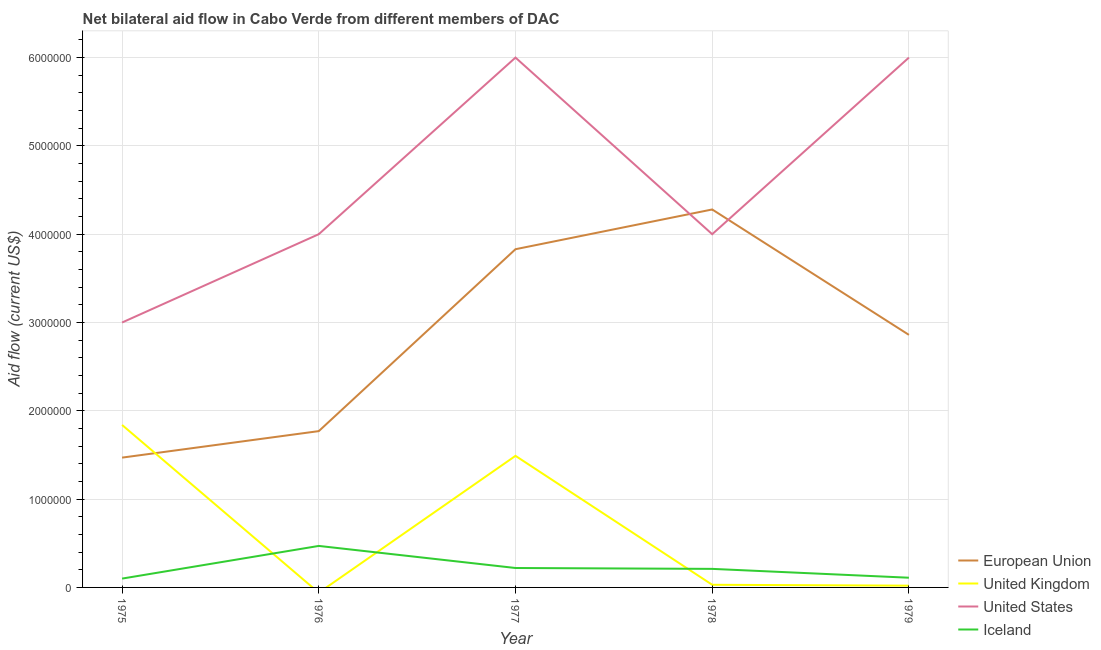How many different coloured lines are there?
Make the answer very short. 4. Is the number of lines equal to the number of legend labels?
Provide a succinct answer. No. What is the amount of aid given by uk in 1979?
Keep it short and to the point. 2.00e+04. Across all years, what is the maximum amount of aid given by eu?
Your response must be concise. 4.28e+06. Across all years, what is the minimum amount of aid given by iceland?
Give a very brief answer. 1.00e+05. In which year was the amount of aid given by iceland maximum?
Keep it short and to the point. 1976. What is the total amount of aid given by uk in the graph?
Your response must be concise. 3.38e+06. What is the difference between the amount of aid given by eu in 1976 and that in 1978?
Offer a very short reply. -2.51e+06. What is the difference between the amount of aid given by us in 1978 and the amount of aid given by iceland in 1977?
Make the answer very short. 3.78e+06. What is the average amount of aid given by iceland per year?
Provide a short and direct response. 2.22e+05. In the year 1979, what is the difference between the amount of aid given by iceland and amount of aid given by us?
Provide a succinct answer. -5.89e+06. In how many years, is the amount of aid given by uk greater than 1600000 US$?
Make the answer very short. 1. What is the ratio of the amount of aid given by uk in 1975 to that in 1979?
Your answer should be compact. 92. Is the difference between the amount of aid given by uk in 1977 and 1979 greater than the difference between the amount of aid given by us in 1977 and 1979?
Provide a succinct answer. Yes. What is the difference between the highest and the lowest amount of aid given by uk?
Make the answer very short. 1.84e+06. Is the sum of the amount of aid given by us in 1975 and 1979 greater than the maximum amount of aid given by iceland across all years?
Ensure brevity in your answer.  Yes. Is it the case that in every year, the sum of the amount of aid given by eu and amount of aid given by iceland is greater than the sum of amount of aid given by uk and amount of aid given by us?
Your answer should be very brief. No. Does the amount of aid given by eu monotonically increase over the years?
Make the answer very short. No. Is the amount of aid given by eu strictly less than the amount of aid given by uk over the years?
Your response must be concise. No. How many lines are there?
Your answer should be compact. 4. How many years are there in the graph?
Your answer should be very brief. 5. Where does the legend appear in the graph?
Provide a succinct answer. Bottom right. What is the title of the graph?
Give a very brief answer. Net bilateral aid flow in Cabo Verde from different members of DAC. Does "Water" appear as one of the legend labels in the graph?
Your response must be concise. No. What is the label or title of the Y-axis?
Provide a succinct answer. Aid flow (current US$). What is the Aid flow (current US$) of European Union in 1975?
Make the answer very short. 1.47e+06. What is the Aid flow (current US$) in United Kingdom in 1975?
Your answer should be very brief. 1.84e+06. What is the Aid flow (current US$) of United States in 1975?
Make the answer very short. 3.00e+06. What is the Aid flow (current US$) in Iceland in 1975?
Provide a short and direct response. 1.00e+05. What is the Aid flow (current US$) in European Union in 1976?
Offer a terse response. 1.77e+06. What is the Aid flow (current US$) in United Kingdom in 1976?
Keep it short and to the point. 0. What is the Aid flow (current US$) of United States in 1976?
Your answer should be very brief. 4.00e+06. What is the Aid flow (current US$) of European Union in 1977?
Make the answer very short. 3.83e+06. What is the Aid flow (current US$) of United Kingdom in 1977?
Offer a very short reply. 1.49e+06. What is the Aid flow (current US$) in European Union in 1978?
Offer a terse response. 4.28e+06. What is the Aid flow (current US$) of United Kingdom in 1978?
Your response must be concise. 3.00e+04. What is the Aid flow (current US$) of European Union in 1979?
Your answer should be compact. 2.86e+06. What is the Aid flow (current US$) in United Kingdom in 1979?
Your answer should be compact. 2.00e+04. What is the Aid flow (current US$) of United States in 1979?
Provide a short and direct response. 6.00e+06. What is the Aid flow (current US$) of Iceland in 1979?
Ensure brevity in your answer.  1.10e+05. Across all years, what is the maximum Aid flow (current US$) in European Union?
Ensure brevity in your answer.  4.28e+06. Across all years, what is the maximum Aid flow (current US$) of United Kingdom?
Your response must be concise. 1.84e+06. Across all years, what is the maximum Aid flow (current US$) of Iceland?
Your answer should be very brief. 4.70e+05. Across all years, what is the minimum Aid flow (current US$) of European Union?
Make the answer very short. 1.47e+06. What is the total Aid flow (current US$) of European Union in the graph?
Provide a succinct answer. 1.42e+07. What is the total Aid flow (current US$) in United Kingdom in the graph?
Give a very brief answer. 3.38e+06. What is the total Aid flow (current US$) of United States in the graph?
Your answer should be compact. 2.30e+07. What is the total Aid flow (current US$) of Iceland in the graph?
Give a very brief answer. 1.11e+06. What is the difference between the Aid flow (current US$) of Iceland in 1975 and that in 1976?
Your answer should be very brief. -3.70e+05. What is the difference between the Aid flow (current US$) of European Union in 1975 and that in 1977?
Your response must be concise. -2.36e+06. What is the difference between the Aid flow (current US$) in United Kingdom in 1975 and that in 1977?
Keep it short and to the point. 3.50e+05. What is the difference between the Aid flow (current US$) of United States in 1975 and that in 1977?
Your response must be concise. -3.00e+06. What is the difference between the Aid flow (current US$) in Iceland in 1975 and that in 1977?
Keep it short and to the point. -1.20e+05. What is the difference between the Aid flow (current US$) in European Union in 1975 and that in 1978?
Your answer should be very brief. -2.81e+06. What is the difference between the Aid flow (current US$) in United Kingdom in 1975 and that in 1978?
Make the answer very short. 1.81e+06. What is the difference between the Aid flow (current US$) of United States in 1975 and that in 1978?
Make the answer very short. -1.00e+06. What is the difference between the Aid flow (current US$) in European Union in 1975 and that in 1979?
Your answer should be very brief. -1.39e+06. What is the difference between the Aid flow (current US$) in United Kingdom in 1975 and that in 1979?
Make the answer very short. 1.82e+06. What is the difference between the Aid flow (current US$) in United States in 1975 and that in 1979?
Offer a very short reply. -3.00e+06. What is the difference between the Aid flow (current US$) in Iceland in 1975 and that in 1979?
Offer a very short reply. -10000. What is the difference between the Aid flow (current US$) of European Union in 1976 and that in 1977?
Provide a succinct answer. -2.06e+06. What is the difference between the Aid flow (current US$) in Iceland in 1976 and that in 1977?
Give a very brief answer. 2.50e+05. What is the difference between the Aid flow (current US$) in European Union in 1976 and that in 1978?
Give a very brief answer. -2.51e+06. What is the difference between the Aid flow (current US$) in United States in 1976 and that in 1978?
Give a very brief answer. 0. What is the difference between the Aid flow (current US$) of European Union in 1976 and that in 1979?
Ensure brevity in your answer.  -1.09e+06. What is the difference between the Aid flow (current US$) in United States in 1976 and that in 1979?
Your answer should be compact. -2.00e+06. What is the difference between the Aid flow (current US$) of European Union in 1977 and that in 1978?
Give a very brief answer. -4.50e+05. What is the difference between the Aid flow (current US$) of United Kingdom in 1977 and that in 1978?
Give a very brief answer. 1.46e+06. What is the difference between the Aid flow (current US$) of European Union in 1977 and that in 1979?
Offer a terse response. 9.70e+05. What is the difference between the Aid flow (current US$) of United Kingdom in 1977 and that in 1979?
Offer a very short reply. 1.47e+06. What is the difference between the Aid flow (current US$) in Iceland in 1977 and that in 1979?
Make the answer very short. 1.10e+05. What is the difference between the Aid flow (current US$) in European Union in 1978 and that in 1979?
Ensure brevity in your answer.  1.42e+06. What is the difference between the Aid flow (current US$) in United Kingdom in 1978 and that in 1979?
Your answer should be compact. 10000. What is the difference between the Aid flow (current US$) of Iceland in 1978 and that in 1979?
Give a very brief answer. 1.00e+05. What is the difference between the Aid flow (current US$) of European Union in 1975 and the Aid flow (current US$) of United States in 1976?
Make the answer very short. -2.53e+06. What is the difference between the Aid flow (current US$) in United Kingdom in 1975 and the Aid flow (current US$) in United States in 1976?
Your response must be concise. -2.16e+06. What is the difference between the Aid flow (current US$) of United Kingdom in 1975 and the Aid flow (current US$) of Iceland in 1976?
Your answer should be compact. 1.37e+06. What is the difference between the Aid flow (current US$) in United States in 1975 and the Aid flow (current US$) in Iceland in 1976?
Give a very brief answer. 2.53e+06. What is the difference between the Aid flow (current US$) in European Union in 1975 and the Aid flow (current US$) in United Kingdom in 1977?
Your answer should be compact. -2.00e+04. What is the difference between the Aid flow (current US$) in European Union in 1975 and the Aid flow (current US$) in United States in 1977?
Provide a short and direct response. -4.53e+06. What is the difference between the Aid flow (current US$) of European Union in 1975 and the Aid flow (current US$) of Iceland in 1977?
Keep it short and to the point. 1.25e+06. What is the difference between the Aid flow (current US$) of United Kingdom in 1975 and the Aid flow (current US$) of United States in 1977?
Ensure brevity in your answer.  -4.16e+06. What is the difference between the Aid flow (current US$) in United Kingdom in 1975 and the Aid flow (current US$) in Iceland in 1977?
Give a very brief answer. 1.62e+06. What is the difference between the Aid flow (current US$) of United States in 1975 and the Aid flow (current US$) of Iceland in 1977?
Provide a short and direct response. 2.78e+06. What is the difference between the Aid flow (current US$) in European Union in 1975 and the Aid flow (current US$) in United Kingdom in 1978?
Offer a very short reply. 1.44e+06. What is the difference between the Aid flow (current US$) of European Union in 1975 and the Aid flow (current US$) of United States in 1978?
Give a very brief answer. -2.53e+06. What is the difference between the Aid flow (current US$) in European Union in 1975 and the Aid flow (current US$) in Iceland in 1978?
Make the answer very short. 1.26e+06. What is the difference between the Aid flow (current US$) of United Kingdom in 1975 and the Aid flow (current US$) of United States in 1978?
Your answer should be compact. -2.16e+06. What is the difference between the Aid flow (current US$) of United Kingdom in 1975 and the Aid flow (current US$) of Iceland in 1978?
Offer a very short reply. 1.63e+06. What is the difference between the Aid flow (current US$) of United States in 1975 and the Aid flow (current US$) of Iceland in 1978?
Give a very brief answer. 2.79e+06. What is the difference between the Aid flow (current US$) of European Union in 1975 and the Aid flow (current US$) of United Kingdom in 1979?
Ensure brevity in your answer.  1.45e+06. What is the difference between the Aid flow (current US$) in European Union in 1975 and the Aid flow (current US$) in United States in 1979?
Your answer should be very brief. -4.53e+06. What is the difference between the Aid flow (current US$) of European Union in 1975 and the Aid flow (current US$) of Iceland in 1979?
Ensure brevity in your answer.  1.36e+06. What is the difference between the Aid flow (current US$) in United Kingdom in 1975 and the Aid flow (current US$) in United States in 1979?
Ensure brevity in your answer.  -4.16e+06. What is the difference between the Aid flow (current US$) of United Kingdom in 1975 and the Aid flow (current US$) of Iceland in 1979?
Keep it short and to the point. 1.73e+06. What is the difference between the Aid flow (current US$) in United States in 1975 and the Aid flow (current US$) in Iceland in 1979?
Your response must be concise. 2.89e+06. What is the difference between the Aid flow (current US$) of European Union in 1976 and the Aid flow (current US$) of United States in 1977?
Offer a very short reply. -4.23e+06. What is the difference between the Aid flow (current US$) in European Union in 1976 and the Aid flow (current US$) in Iceland in 1977?
Your answer should be compact. 1.55e+06. What is the difference between the Aid flow (current US$) in United States in 1976 and the Aid flow (current US$) in Iceland in 1977?
Provide a short and direct response. 3.78e+06. What is the difference between the Aid flow (current US$) in European Union in 1976 and the Aid flow (current US$) in United Kingdom in 1978?
Ensure brevity in your answer.  1.74e+06. What is the difference between the Aid flow (current US$) of European Union in 1976 and the Aid flow (current US$) of United States in 1978?
Provide a succinct answer. -2.23e+06. What is the difference between the Aid flow (current US$) in European Union in 1976 and the Aid flow (current US$) in Iceland in 1978?
Your response must be concise. 1.56e+06. What is the difference between the Aid flow (current US$) of United States in 1976 and the Aid flow (current US$) of Iceland in 1978?
Provide a succinct answer. 3.79e+06. What is the difference between the Aid flow (current US$) of European Union in 1976 and the Aid flow (current US$) of United Kingdom in 1979?
Make the answer very short. 1.75e+06. What is the difference between the Aid flow (current US$) in European Union in 1976 and the Aid flow (current US$) in United States in 1979?
Ensure brevity in your answer.  -4.23e+06. What is the difference between the Aid flow (current US$) of European Union in 1976 and the Aid flow (current US$) of Iceland in 1979?
Offer a very short reply. 1.66e+06. What is the difference between the Aid flow (current US$) in United States in 1976 and the Aid flow (current US$) in Iceland in 1979?
Provide a succinct answer. 3.89e+06. What is the difference between the Aid flow (current US$) of European Union in 1977 and the Aid flow (current US$) of United Kingdom in 1978?
Provide a short and direct response. 3.80e+06. What is the difference between the Aid flow (current US$) of European Union in 1977 and the Aid flow (current US$) of Iceland in 1978?
Provide a short and direct response. 3.62e+06. What is the difference between the Aid flow (current US$) of United Kingdom in 1977 and the Aid flow (current US$) of United States in 1978?
Keep it short and to the point. -2.51e+06. What is the difference between the Aid flow (current US$) of United Kingdom in 1977 and the Aid flow (current US$) of Iceland in 1978?
Make the answer very short. 1.28e+06. What is the difference between the Aid flow (current US$) in United States in 1977 and the Aid flow (current US$) in Iceland in 1978?
Provide a succinct answer. 5.79e+06. What is the difference between the Aid flow (current US$) in European Union in 1977 and the Aid flow (current US$) in United Kingdom in 1979?
Offer a very short reply. 3.81e+06. What is the difference between the Aid flow (current US$) of European Union in 1977 and the Aid flow (current US$) of United States in 1979?
Provide a short and direct response. -2.17e+06. What is the difference between the Aid flow (current US$) of European Union in 1977 and the Aid flow (current US$) of Iceland in 1979?
Your response must be concise. 3.72e+06. What is the difference between the Aid flow (current US$) in United Kingdom in 1977 and the Aid flow (current US$) in United States in 1979?
Your answer should be very brief. -4.51e+06. What is the difference between the Aid flow (current US$) of United Kingdom in 1977 and the Aid flow (current US$) of Iceland in 1979?
Provide a succinct answer. 1.38e+06. What is the difference between the Aid flow (current US$) in United States in 1977 and the Aid flow (current US$) in Iceland in 1979?
Give a very brief answer. 5.89e+06. What is the difference between the Aid flow (current US$) in European Union in 1978 and the Aid flow (current US$) in United Kingdom in 1979?
Give a very brief answer. 4.26e+06. What is the difference between the Aid flow (current US$) of European Union in 1978 and the Aid flow (current US$) of United States in 1979?
Make the answer very short. -1.72e+06. What is the difference between the Aid flow (current US$) of European Union in 1978 and the Aid flow (current US$) of Iceland in 1979?
Your answer should be compact. 4.17e+06. What is the difference between the Aid flow (current US$) in United Kingdom in 1978 and the Aid flow (current US$) in United States in 1979?
Provide a short and direct response. -5.97e+06. What is the difference between the Aid flow (current US$) in United Kingdom in 1978 and the Aid flow (current US$) in Iceland in 1979?
Provide a short and direct response. -8.00e+04. What is the difference between the Aid flow (current US$) of United States in 1978 and the Aid flow (current US$) of Iceland in 1979?
Offer a very short reply. 3.89e+06. What is the average Aid flow (current US$) in European Union per year?
Give a very brief answer. 2.84e+06. What is the average Aid flow (current US$) in United Kingdom per year?
Provide a succinct answer. 6.76e+05. What is the average Aid flow (current US$) of United States per year?
Provide a short and direct response. 4.60e+06. What is the average Aid flow (current US$) in Iceland per year?
Your response must be concise. 2.22e+05. In the year 1975, what is the difference between the Aid flow (current US$) in European Union and Aid flow (current US$) in United Kingdom?
Offer a terse response. -3.70e+05. In the year 1975, what is the difference between the Aid flow (current US$) of European Union and Aid flow (current US$) of United States?
Keep it short and to the point. -1.53e+06. In the year 1975, what is the difference between the Aid flow (current US$) in European Union and Aid flow (current US$) in Iceland?
Ensure brevity in your answer.  1.37e+06. In the year 1975, what is the difference between the Aid flow (current US$) of United Kingdom and Aid flow (current US$) of United States?
Provide a short and direct response. -1.16e+06. In the year 1975, what is the difference between the Aid flow (current US$) of United Kingdom and Aid flow (current US$) of Iceland?
Your answer should be compact. 1.74e+06. In the year 1975, what is the difference between the Aid flow (current US$) in United States and Aid flow (current US$) in Iceland?
Offer a very short reply. 2.90e+06. In the year 1976, what is the difference between the Aid flow (current US$) in European Union and Aid flow (current US$) in United States?
Ensure brevity in your answer.  -2.23e+06. In the year 1976, what is the difference between the Aid flow (current US$) of European Union and Aid flow (current US$) of Iceland?
Provide a succinct answer. 1.30e+06. In the year 1976, what is the difference between the Aid flow (current US$) of United States and Aid flow (current US$) of Iceland?
Provide a short and direct response. 3.53e+06. In the year 1977, what is the difference between the Aid flow (current US$) in European Union and Aid flow (current US$) in United Kingdom?
Give a very brief answer. 2.34e+06. In the year 1977, what is the difference between the Aid flow (current US$) of European Union and Aid flow (current US$) of United States?
Provide a short and direct response. -2.17e+06. In the year 1977, what is the difference between the Aid flow (current US$) in European Union and Aid flow (current US$) in Iceland?
Give a very brief answer. 3.61e+06. In the year 1977, what is the difference between the Aid flow (current US$) in United Kingdom and Aid flow (current US$) in United States?
Offer a very short reply. -4.51e+06. In the year 1977, what is the difference between the Aid flow (current US$) of United Kingdom and Aid flow (current US$) of Iceland?
Keep it short and to the point. 1.27e+06. In the year 1977, what is the difference between the Aid flow (current US$) in United States and Aid flow (current US$) in Iceland?
Offer a terse response. 5.78e+06. In the year 1978, what is the difference between the Aid flow (current US$) of European Union and Aid flow (current US$) of United Kingdom?
Ensure brevity in your answer.  4.25e+06. In the year 1978, what is the difference between the Aid flow (current US$) of European Union and Aid flow (current US$) of United States?
Your answer should be compact. 2.80e+05. In the year 1978, what is the difference between the Aid flow (current US$) in European Union and Aid flow (current US$) in Iceland?
Keep it short and to the point. 4.07e+06. In the year 1978, what is the difference between the Aid flow (current US$) of United Kingdom and Aid flow (current US$) of United States?
Your answer should be very brief. -3.97e+06. In the year 1978, what is the difference between the Aid flow (current US$) in United States and Aid flow (current US$) in Iceland?
Ensure brevity in your answer.  3.79e+06. In the year 1979, what is the difference between the Aid flow (current US$) of European Union and Aid flow (current US$) of United Kingdom?
Give a very brief answer. 2.84e+06. In the year 1979, what is the difference between the Aid flow (current US$) of European Union and Aid flow (current US$) of United States?
Give a very brief answer. -3.14e+06. In the year 1979, what is the difference between the Aid flow (current US$) in European Union and Aid flow (current US$) in Iceland?
Your response must be concise. 2.75e+06. In the year 1979, what is the difference between the Aid flow (current US$) in United Kingdom and Aid flow (current US$) in United States?
Provide a succinct answer. -5.98e+06. In the year 1979, what is the difference between the Aid flow (current US$) of United States and Aid flow (current US$) of Iceland?
Offer a terse response. 5.89e+06. What is the ratio of the Aid flow (current US$) of European Union in 1975 to that in 1976?
Your answer should be compact. 0.83. What is the ratio of the Aid flow (current US$) in United States in 1975 to that in 1976?
Offer a terse response. 0.75. What is the ratio of the Aid flow (current US$) of Iceland in 1975 to that in 1976?
Make the answer very short. 0.21. What is the ratio of the Aid flow (current US$) of European Union in 1975 to that in 1977?
Offer a very short reply. 0.38. What is the ratio of the Aid flow (current US$) of United Kingdom in 1975 to that in 1977?
Give a very brief answer. 1.23. What is the ratio of the Aid flow (current US$) of United States in 1975 to that in 1977?
Your answer should be very brief. 0.5. What is the ratio of the Aid flow (current US$) of Iceland in 1975 to that in 1977?
Keep it short and to the point. 0.45. What is the ratio of the Aid flow (current US$) of European Union in 1975 to that in 1978?
Your answer should be compact. 0.34. What is the ratio of the Aid flow (current US$) in United Kingdom in 1975 to that in 1978?
Provide a succinct answer. 61.33. What is the ratio of the Aid flow (current US$) of Iceland in 1975 to that in 1978?
Your answer should be compact. 0.48. What is the ratio of the Aid flow (current US$) in European Union in 1975 to that in 1979?
Offer a terse response. 0.51. What is the ratio of the Aid flow (current US$) of United Kingdom in 1975 to that in 1979?
Keep it short and to the point. 92. What is the ratio of the Aid flow (current US$) of Iceland in 1975 to that in 1979?
Your answer should be very brief. 0.91. What is the ratio of the Aid flow (current US$) in European Union in 1976 to that in 1977?
Your response must be concise. 0.46. What is the ratio of the Aid flow (current US$) in Iceland in 1976 to that in 1977?
Give a very brief answer. 2.14. What is the ratio of the Aid flow (current US$) of European Union in 1976 to that in 1978?
Your answer should be compact. 0.41. What is the ratio of the Aid flow (current US$) in Iceland in 1976 to that in 1978?
Provide a succinct answer. 2.24. What is the ratio of the Aid flow (current US$) in European Union in 1976 to that in 1979?
Your answer should be very brief. 0.62. What is the ratio of the Aid flow (current US$) in Iceland in 1976 to that in 1979?
Ensure brevity in your answer.  4.27. What is the ratio of the Aid flow (current US$) in European Union in 1977 to that in 1978?
Your response must be concise. 0.89. What is the ratio of the Aid flow (current US$) of United Kingdom in 1977 to that in 1978?
Give a very brief answer. 49.67. What is the ratio of the Aid flow (current US$) in Iceland in 1977 to that in 1978?
Keep it short and to the point. 1.05. What is the ratio of the Aid flow (current US$) of European Union in 1977 to that in 1979?
Your answer should be compact. 1.34. What is the ratio of the Aid flow (current US$) of United Kingdom in 1977 to that in 1979?
Your answer should be very brief. 74.5. What is the ratio of the Aid flow (current US$) in United States in 1977 to that in 1979?
Offer a terse response. 1. What is the ratio of the Aid flow (current US$) of European Union in 1978 to that in 1979?
Give a very brief answer. 1.5. What is the ratio of the Aid flow (current US$) of United Kingdom in 1978 to that in 1979?
Make the answer very short. 1.5. What is the ratio of the Aid flow (current US$) of Iceland in 1978 to that in 1979?
Offer a terse response. 1.91. What is the difference between the highest and the second highest Aid flow (current US$) of European Union?
Keep it short and to the point. 4.50e+05. What is the difference between the highest and the lowest Aid flow (current US$) in European Union?
Make the answer very short. 2.81e+06. What is the difference between the highest and the lowest Aid flow (current US$) of United Kingdom?
Offer a very short reply. 1.84e+06. What is the difference between the highest and the lowest Aid flow (current US$) in United States?
Keep it short and to the point. 3.00e+06. What is the difference between the highest and the lowest Aid flow (current US$) of Iceland?
Your response must be concise. 3.70e+05. 